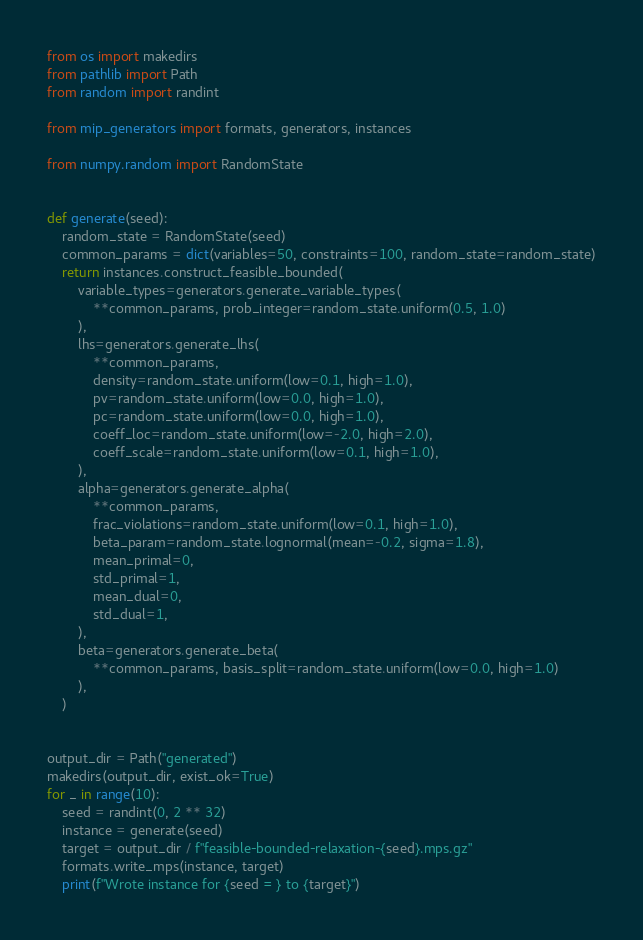Convert code to text. <code><loc_0><loc_0><loc_500><loc_500><_Python_>from os import makedirs
from pathlib import Path
from random import randint

from mip_generators import formats, generators, instances

from numpy.random import RandomState


def generate(seed):
    random_state = RandomState(seed)
    common_params = dict(variables=50, constraints=100, random_state=random_state)
    return instances.construct_feasible_bounded(
        variable_types=generators.generate_variable_types(
            **common_params, prob_integer=random_state.uniform(0.5, 1.0)
        ),
        lhs=generators.generate_lhs(
            **common_params,
            density=random_state.uniform(low=0.1, high=1.0),
            pv=random_state.uniform(low=0.0, high=1.0),
            pc=random_state.uniform(low=0.0, high=1.0),
            coeff_loc=random_state.uniform(low=-2.0, high=2.0),
            coeff_scale=random_state.uniform(low=0.1, high=1.0),
        ),
        alpha=generators.generate_alpha(
            **common_params,
            frac_violations=random_state.uniform(low=0.1, high=1.0),
            beta_param=random_state.lognormal(mean=-0.2, sigma=1.8),
            mean_primal=0,
            std_primal=1,
            mean_dual=0,
            std_dual=1,
        ),
        beta=generators.generate_beta(
            **common_params, basis_split=random_state.uniform(low=0.0, high=1.0)
        ),
    )


output_dir = Path("generated")
makedirs(output_dir, exist_ok=True)
for _ in range(10):
    seed = randint(0, 2 ** 32)
    instance = generate(seed)
    target = output_dir / f"feasible-bounded-relaxation-{seed}.mps.gz"
    formats.write_mps(instance, target)
    print(f"Wrote instance for {seed = } to {target}")
</code> 